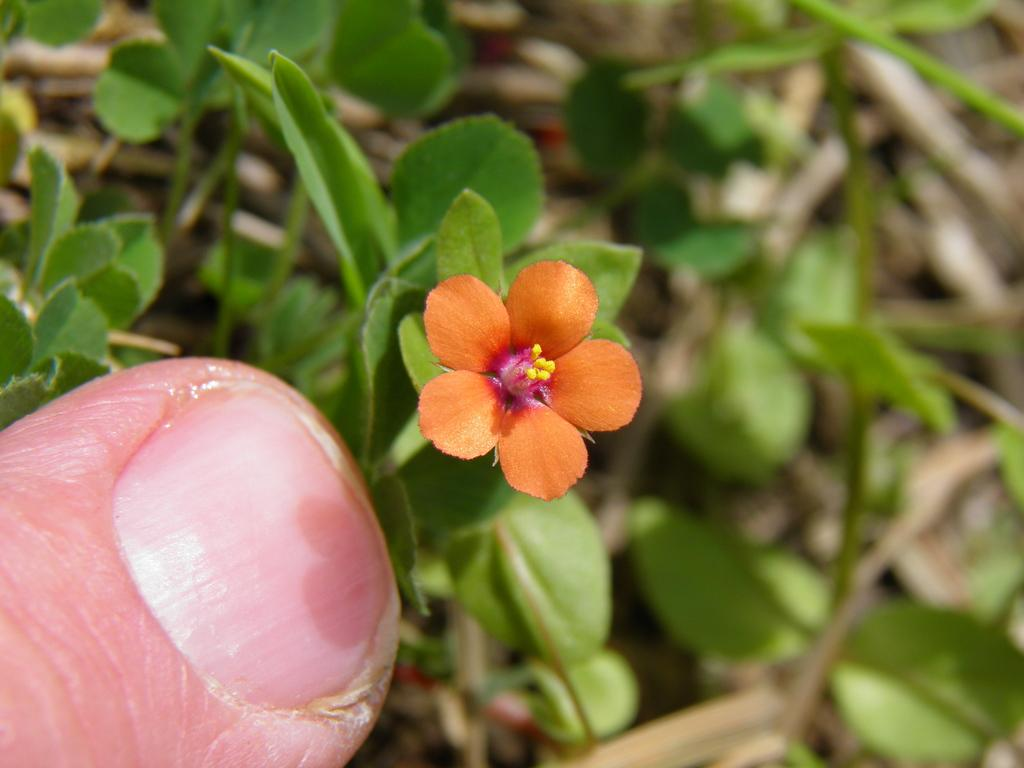What is the main subject in the center of the image? There is a flower in the center of the image. Can you describe any other elements in the image? There is a person's finger visible at the bottom left corner of the image, and there are plants in the background of the image. What language is the flower speaking in the image? The flower is not speaking in the image, and therefore, there is no language associated with it. 